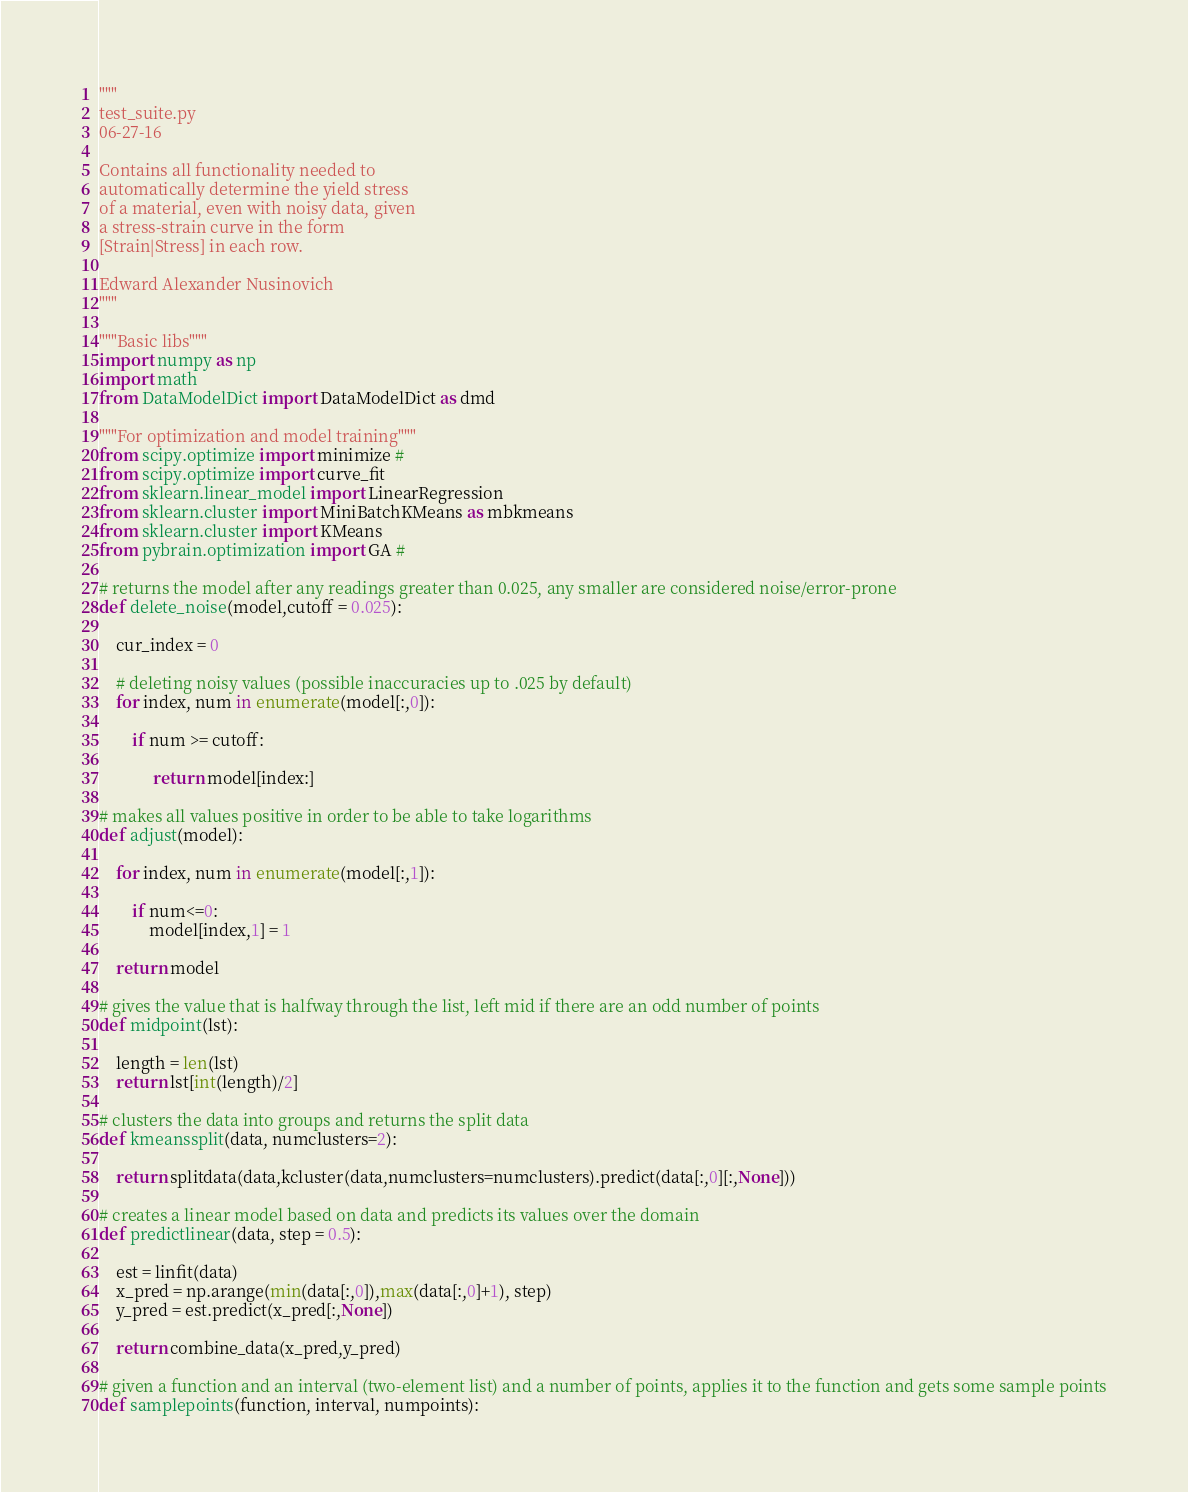Convert code to text. <code><loc_0><loc_0><loc_500><loc_500><_Python_>"""
test_suite.py
06-27-16

Contains all functionality needed to
automatically determine the yield stress
of a material, even with noisy data, given
a stress-strain curve in the form
[Strain|Stress] in each row.

Edward Alexander Nusinovich
"""

"""Basic libs"""
import numpy as np
import math
from DataModelDict import DataModelDict as dmd

"""For optimization and model training"""
from scipy.optimize import minimize #
from scipy.optimize import curve_fit
from sklearn.linear_model import LinearRegression
from sklearn.cluster import MiniBatchKMeans as mbkmeans
from sklearn.cluster import KMeans
from pybrain.optimization import GA #

# returns the model after any readings greater than 0.025, any smaller are considered noise/error-prone
def delete_noise(model,cutoff = 0.025):
    
    cur_index = 0

    # deleting noisy values (possible inaccuracies up to .025 by default)
    for index, num in enumerate(model[:,0]):
        
        if num >= cutoff: 
              
             return model[index:]   
             
# makes all values positive in order to be able to take logarithms
def adjust(model):
    
    for index, num in enumerate(model[:,1]):
        
        if num<=0:
            model[index,1] = 1
        
    return model

# gives the value that is halfway through the list, left mid if there are an odd number of points
def midpoint(lst):
    
    length = len(lst)
    return lst[int(length)/2]

# clusters the data into groups and returns the split data
def kmeanssplit(data, numclusters=2):
    
    return splitdata(data,kcluster(data,numclusters=numclusters).predict(data[:,0][:,None]))

# creates a linear model based on data and predicts its values over the domain
def predictlinear(data, step = 0.5):
    
    est = linfit(data)
    x_pred = np.arange(min(data[:,0]),max(data[:,0]+1), step)
    y_pred = est.predict(x_pred[:,None])
    
    return combine_data(x_pred,y_pred)

# given a function and an interval (two-element list) and a number of points, applies it to the function and gets some sample points
def samplepoints(function, interval, numpoints):
</code> 